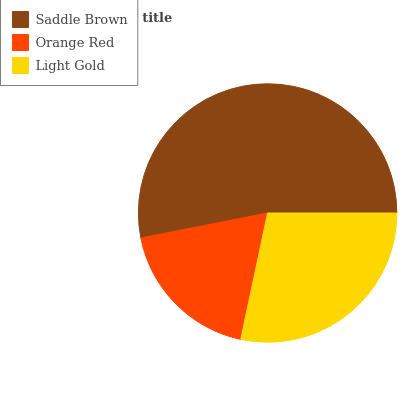Is Orange Red the minimum?
Answer yes or no. Yes. Is Saddle Brown the maximum?
Answer yes or no. Yes. Is Light Gold the minimum?
Answer yes or no. No. Is Light Gold the maximum?
Answer yes or no. No. Is Light Gold greater than Orange Red?
Answer yes or no. Yes. Is Orange Red less than Light Gold?
Answer yes or no. Yes. Is Orange Red greater than Light Gold?
Answer yes or no. No. Is Light Gold less than Orange Red?
Answer yes or no. No. Is Light Gold the high median?
Answer yes or no. Yes. Is Light Gold the low median?
Answer yes or no. Yes. Is Orange Red the high median?
Answer yes or no. No. Is Orange Red the low median?
Answer yes or no. No. 